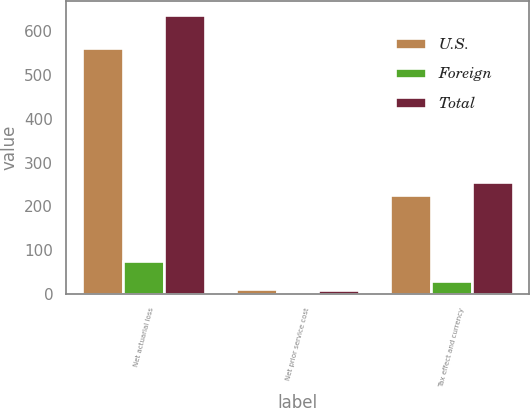Convert chart to OTSL. <chart><loc_0><loc_0><loc_500><loc_500><stacked_bar_chart><ecel><fcel>Net actuarial loss<fcel>Net prior service cost<fcel>Tax effect and currency<nl><fcel>U.S.<fcel>561.3<fcel>11.9<fcel>224.8<nl><fcel>Foreign<fcel>75.7<fcel>3.2<fcel>30.1<nl><fcel>Total<fcel>637<fcel>8.7<fcel>254.9<nl></chart> 